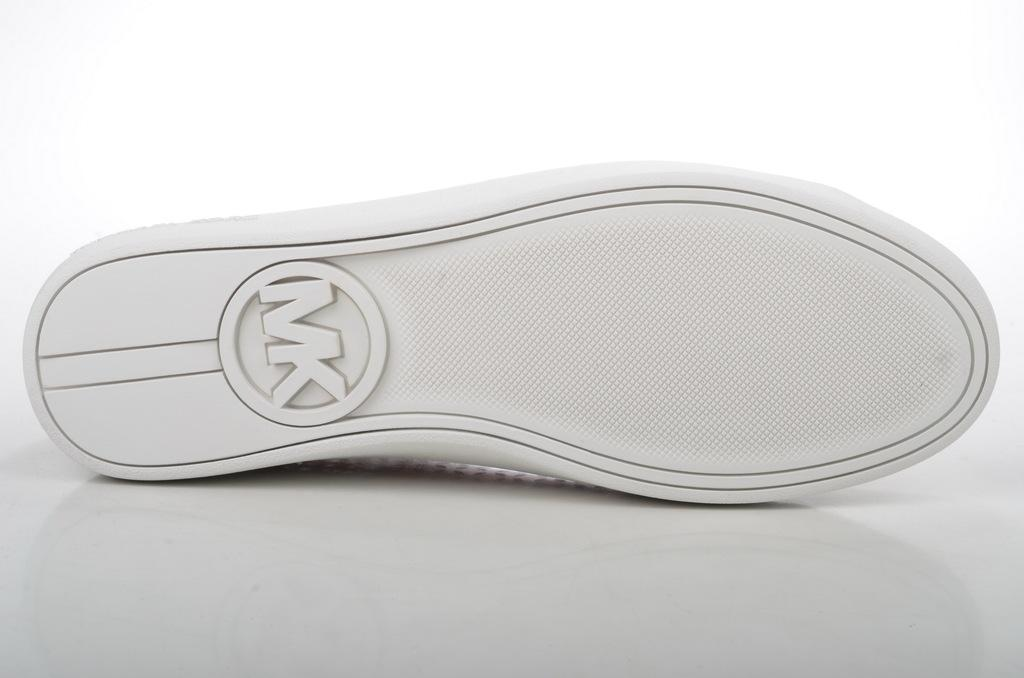What object is the main focus of the image? There is a shoe in the image. What type of oatmeal is being prepared in the image? There is no oatmeal present in the image; it only features a shoe. Is the shoe attacking someone in the image? No, the shoe is not attacking anyone in the image; it is simply an object being depicted. 